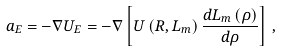<formula> <loc_0><loc_0><loc_500><loc_500>\vec { a } _ { E } = - \nabla U _ { E } = - \nabla \left [ U \left ( R , L _ { m } \right ) \frac { d L _ { m } \left ( \rho \right ) } { d \rho } \right ] \, ,</formula> 